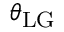<formula> <loc_0><loc_0><loc_500><loc_500>\theta _ { L G }</formula> 